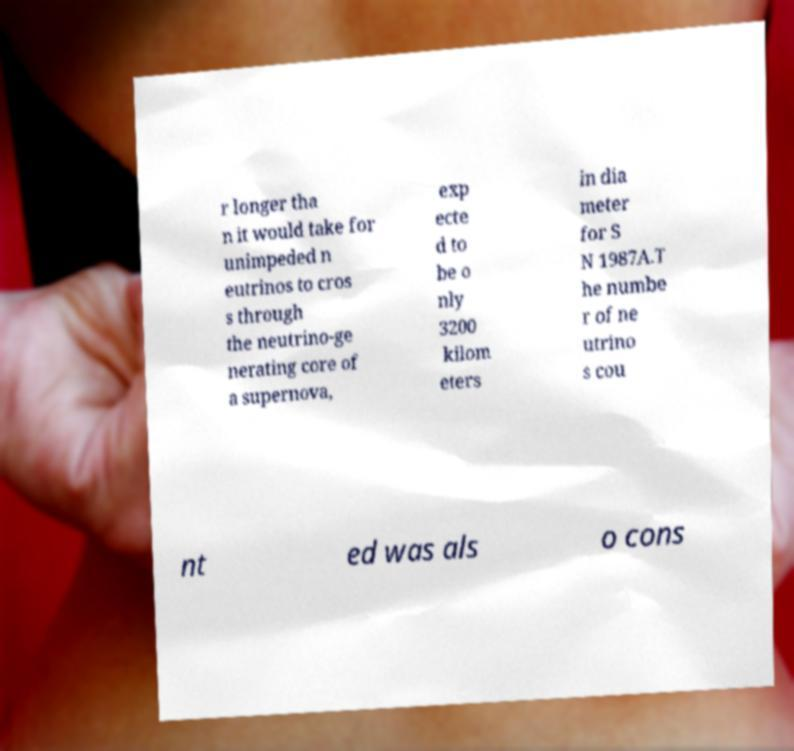For documentation purposes, I need the text within this image transcribed. Could you provide that? r longer tha n it would take for unimpeded n eutrinos to cros s through the neutrino-ge nerating core of a supernova, exp ecte d to be o nly 3200 kilom eters in dia meter for S N 1987A.T he numbe r of ne utrino s cou nt ed was als o cons 